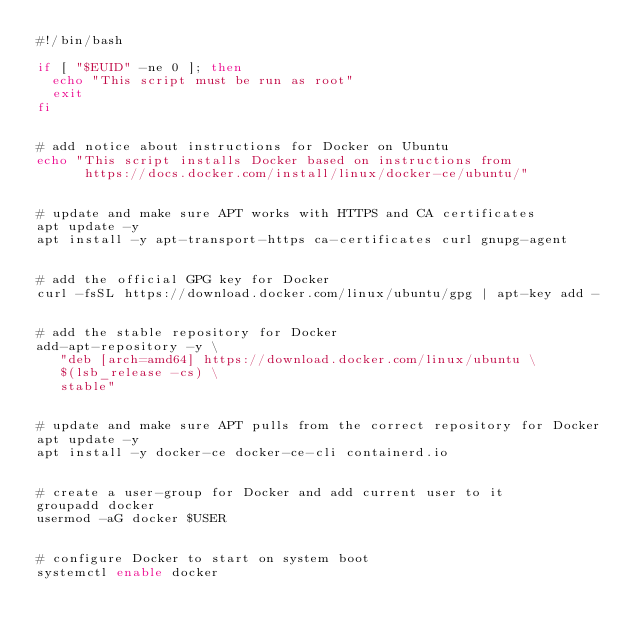<code> <loc_0><loc_0><loc_500><loc_500><_Bash_>#!/bin/bash

if [ "$EUID" -ne 0 ]; then
  echo "This script must be run as root"
  exit
fi


# add notice about instructions for Docker on Ubuntu
echo "This script installs Docker based on instructions from
      https://docs.docker.com/install/linux/docker-ce/ubuntu/"


# update and make sure APT works with HTTPS and CA certificates
apt update -y
apt install -y apt-transport-https ca-certificates curl gnupg-agent


# add the official GPG key for Docker
curl -fsSL https://download.docker.com/linux/ubuntu/gpg | apt-key add -


# add the stable repository for Docker
add-apt-repository -y \
   "deb [arch=amd64] https://download.docker.com/linux/ubuntu \
   $(lsb_release -cs) \
   stable"


# update and make sure APT pulls from the correct repository for Docker
apt update -y
apt install -y docker-ce docker-ce-cli containerd.io


# create a user-group for Docker and add current user to it
groupadd docker
usermod -aG docker $USER


# configure Docker to start on system boot
systemctl enable docker
</code> 